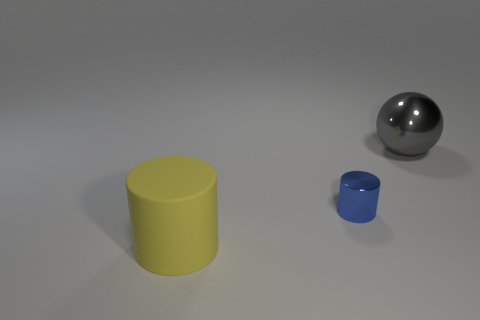Add 1 tiny yellow objects. How many objects exist? 4 Subtract all cylinders. How many objects are left? 1 Add 2 tiny blue cylinders. How many tiny blue cylinders exist? 3 Subtract 0 purple cubes. How many objects are left? 3 Subtract all blue rubber spheres. Subtract all balls. How many objects are left? 2 Add 3 large rubber objects. How many large rubber objects are left? 4 